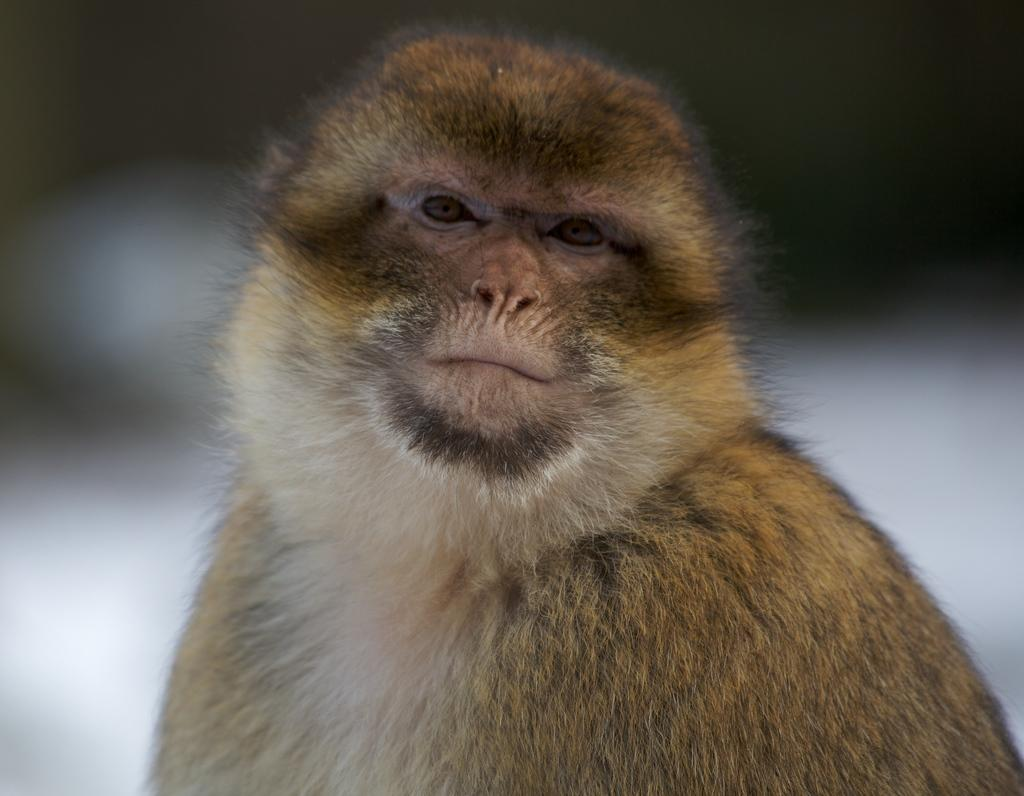What type of animal is in the image? There is a monkey in the image. What type of vegetable is the monkey holding in the image? There is no vegetable present in the image; it only features a monkey. What is the condition of the tent in the image? There is no tent present in the image, so it is not possible to determine its condition. 